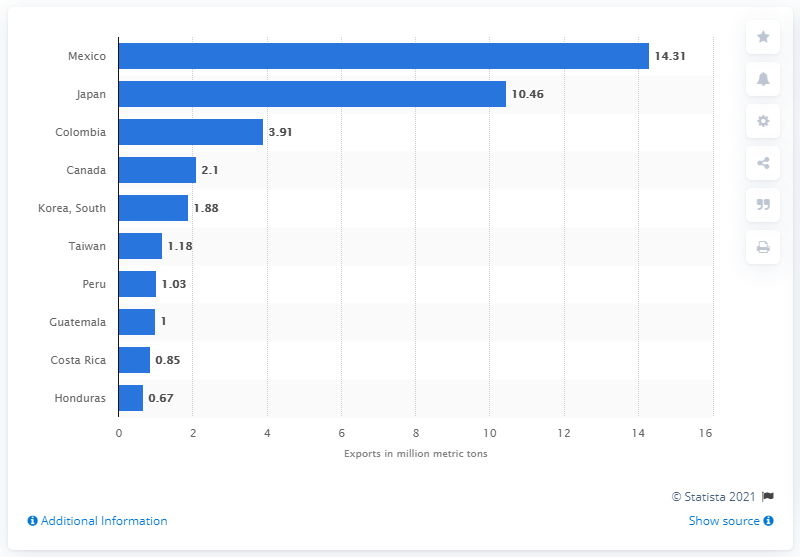Identify some key points in this picture. In 2019, the United States exported 14.31 metric tons of corn to Mexico. 